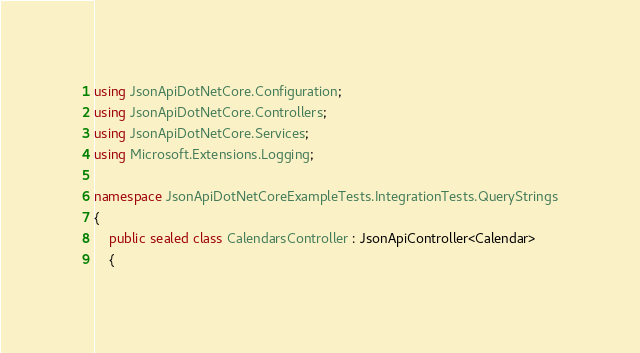<code> <loc_0><loc_0><loc_500><loc_500><_C#_>using JsonApiDotNetCore.Configuration;
using JsonApiDotNetCore.Controllers;
using JsonApiDotNetCore.Services;
using Microsoft.Extensions.Logging;

namespace JsonApiDotNetCoreExampleTests.IntegrationTests.QueryStrings
{
    public sealed class CalendarsController : JsonApiController<Calendar>
    {</code> 